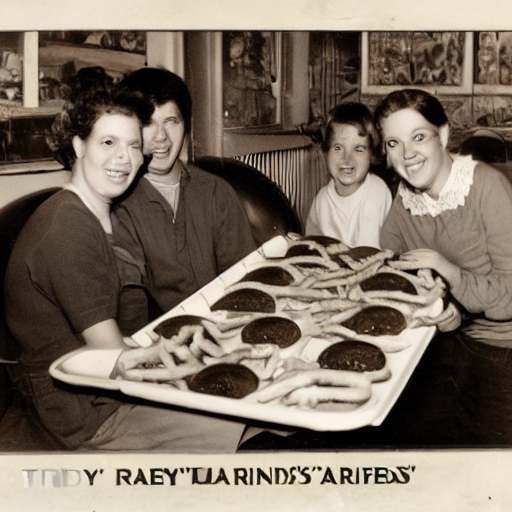What era does this photo seem to be from? The style of clothing and the appearance of the photograph suggest it could be from the mid-20th century, potentially the 1950s or 1960s, which aligns with the popularization of diners and fast food culture during that time. 